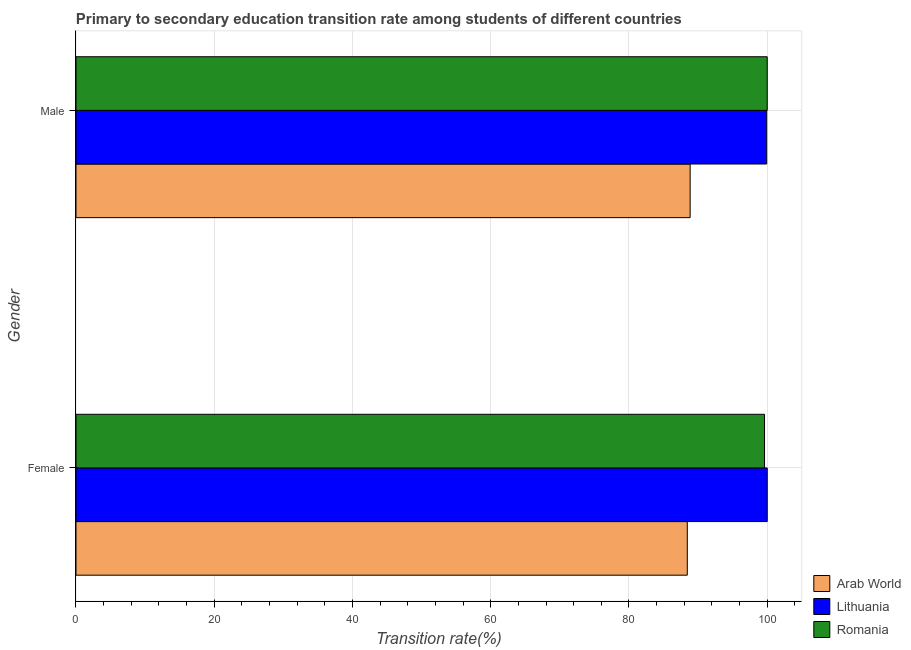How many groups of bars are there?
Give a very brief answer. 2. Are the number of bars per tick equal to the number of legend labels?
Provide a succinct answer. Yes. Are the number of bars on each tick of the Y-axis equal?
Your answer should be very brief. Yes. How many bars are there on the 1st tick from the top?
Offer a terse response. 3. What is the label of the 2nd group of bars from the top?
Keep it short and to the point. Female. What is the transition rate among male students in Arab World?
Your answer should be very brief. 88.85. Across all countries, what is the maximum transition rate among male students?
Offer a terse response. 100. Across all countries, what is the minimum transition rate among male students?
Your answer should be compact. 88.85. In which country was the transition rate among female students maximum?
Provide a succinct answer. Lithuania. In which country was the transition rate among male students minimum?
Offer a very short reply. Arab World. What is the total transition rate among male students in the graph?
Make the answer very short. 288.77. What is the difference between the transition rate among male students in Romania and that in Lithuania?
Offer a very short reply. 0.07. What is the difference between the transition rate among female students in Arab World and the transition rate among male students in Romania?
Provide a short and direct response. -11.56. What is the average transition rate among female students per country?
Offer a terse response. 96.02. What is the difference between the transition rate among female students and transition rate among male students in Lithuania?
Offer a terse response. 0.07. In how many countries, is the transition rate among female students greater than 56 %?
Your response must be concise. 3. What is the ratio of the transition rate among male students in Arab World to that in Romania?
Your response must be concise. 0.89. In how many countries, is the transition rate among female students greater than the average transition rate among female students taken over all countries?
Your response must be concise. 2. What does the 2nd bar from the top in Male represents?
Give a very brief answer. Lithuania. What does the 2nd bar from the bottom in Male represents?
Your answer should be compact. Lithuania. Are all the bars in the graph horizontal?
Make the answer very short. Yes. How many countries are there in the graph?
Keep it short and to the point. 3. What is the difference between two consecutive major ticks on the X-axis?
Ensure brevity in your answer.  20. Does the graph contain any zero values?
Your answer should be compact. No. Does the graph contain grids?
Make the answer very short. Yes. Where does the legend appear in the graph?
Your answer should be compact. Bottom right. How are the legend labels stacked?
Offer a terse response. Vertical. What is the title of the graph?
Make the answer very short. Primary to secondary education transition rate among students of different countries. What is the label or title of the X-axis?
Offer a very short reply. Transition rate(%). What is the Transition rate(%) of Arab World in Female?
Make the answer very short. 88.44. What is the Transition rate(%) of Lithuania in Female?
Your response must be concise. 100. What is the Transition rate(%) in Romania in Female?
Provide a succinct answer. 99.61. What is the Transition rate(%) of Arab World in Male?
Provide a short and direct response. 88.85. What is the Transition rate(%) in Lithuania in Male?
Provide a succinct answer. 99.93. Across all Gender, what is the maximum Transition rate(%) in Arab World?
Offer a terse response. 88.85. Across all Gender, what is the minimum Transition rate(%) in Arab World?
Your response must be concise. 88.44. Across all Gender, what is the minimum Transition rate(%) in Lithuania?
Offer a terse response. 99.93. Across all Gender, what is the minimum Transition rate(%) in Romania?
Offer a terse response. 99.61. What is the total Transition rate(%) in Arab World in the graph?
Your answer should be very brief. 177.29. What is the total Transition rate(%) of Lithuania in the graph?
Make the answer very short. 199.93. What is the total Transition rate(%) in Romania in the graph?
Your answer should be compact. 199.61. What is the difference between the Transition rate(%) in Arab World in Female and that in Male?
Offer a terse response. -0.41. What is the difference between the Transition rate(%) of Lithuania in Female and that in Male?
Your response must be concise. 0.07. What is the difference between the Transition rate(%) of Romania in Female and that in Male?
Your answer should be compact. -0.39. What is the difference between the Transition rate(%) of Arab World in Female and the Transition rate(%) of Lithuania in Male?
Your answer should be very brief. -11.49. What is the difference between the Transition rate(%) of Arab World in Female and the Transition rate(%) of Romania in Male?
Offer a terse response. -11.56. What is the average Transition rate(%) in Arab World per Gender?
Offer a very short reply. 88.64. What is the average Transition rate(%) in Lithuania per Gender?
Your answer should be compact. 99.96. What is the average Transition rate(%) of Romania per Gender?
Offer a terse response. 99.8. What is the difference between the Transition rate(%) of Arab World and Transition rate(%) of Lithuania in Female?
Make the answer very short. -11.56. What is the difference between the Transition rate(%) of Arab World and Transition rate(%) of Romania in Female?
Keep it short and to the point. -11.17. What is the difference between the Transition rate(%) of Lithuania and Transition rate(%) of Romania in Female?
Offer a very short reply. 0.39. What is the difference between the Transition rate(%) in Arab World and Transition rate(%) in Lithuania in Male?
Offer a very short reply. -11.08. What is the difference between the Transition rate(%) in Arab World and Transition rate(%) in Romania in Male?
Offer a very short reply. -11.15. What is the difference between the Transition rate(%) of Lithuania and Transition rate(%) of Romania in Male?
Provide a short and direct response. -0.07. What is the ratio of the Transition rate(%) of Lithuania in Female to that in Male?
Offer a very short reply. 1. What is the difference between the highest and the second highest Transition rate(%) in Arab World?
Make the answer very short. 0.41. What is the difference between the highest and the second highest Transition rate(%) in Lithuania?
Your answer should be compact. 0.07. What is the difference between the highest and the second highest Transition rate(%) of Romania?
Your answer should be very brief. 0.39. What is the difference between the highest and the lowest Transition rate(%) in Arab World?
Your answer should be compact. 0.41. What is the difference between the highest and the lowest Transition rate(%) of Lithuania?
Offer a terse response. 0.07. What is the difference between the highest and the lowest Transition rate(%) in Romania?
Your answer should be very brief. 0.39. 